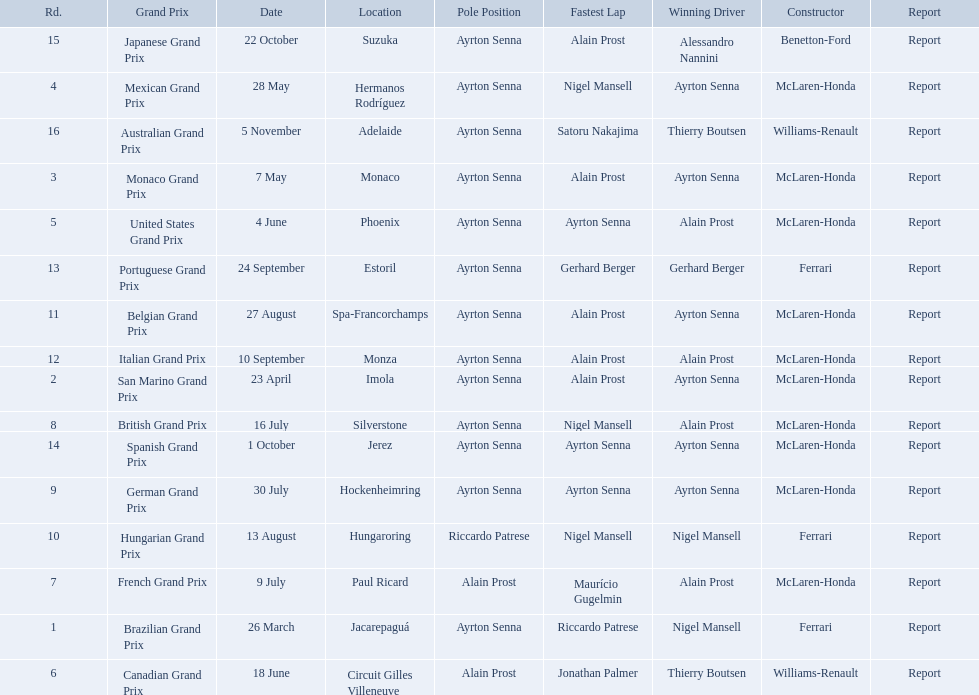Who won the spanish grand prix? McLaren-Honda. Who won the italian grand prix? McLaren-Honda. What grand prix did benneton-ford win? Japanese Grand Prix. 